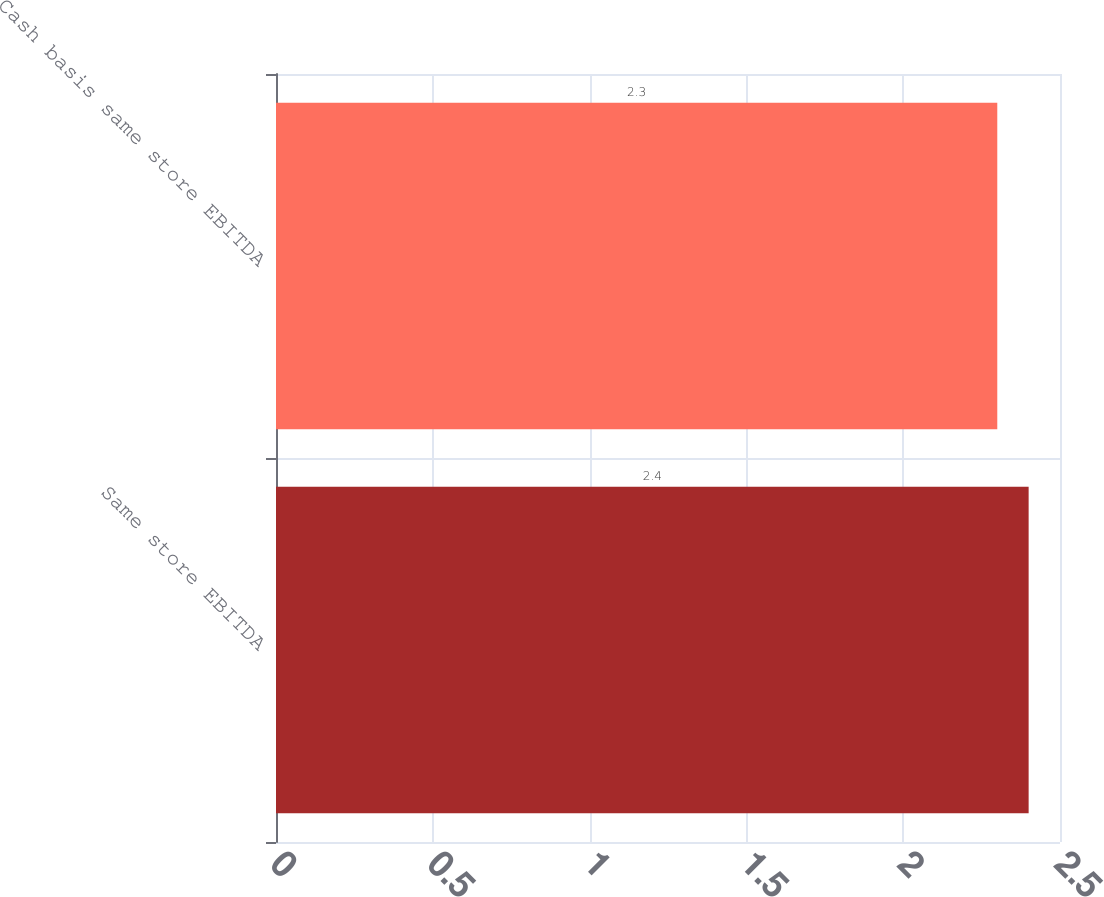Convert chart to OTSL. <chart><loc_0><loc_0><loc_500><loc_500><bar_chart><fcel>Same store EBITDA<fcel>Cash basis same store EBITDA<nl><fcel>2.4<fcel>2.3<nl></chart> 